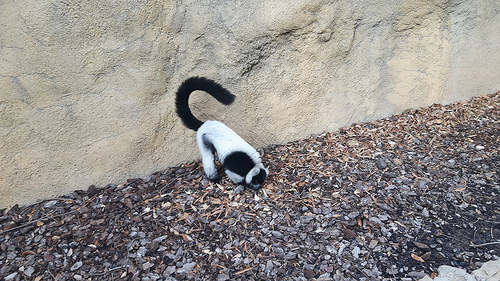<image>
Is there a lemur on the rock? No. The lemur is not positioned on the rock. They may be near each other, but the lemur is not supported by or resting on top of the rock. 